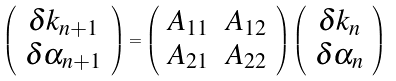Convert formula to latex. <formula><loc_0><loc_0><loc_500><loc_500>\left ( \begin{array} { c } \delta k _ { n + 1 } \\ \delta \alpha _ { n + 1 } \end{array} \right ) = \left ( \begin{array} { c c } A _ { 1 1 } & A _ { 1 2 } \\ A _ { 2 1 } & A _ { 2 2 } \end{array} \right ) \left ( \begin{array} { c } \delta k _ { n } \\ \delta \alpha _ { n } \end{array} \right )</formula> 